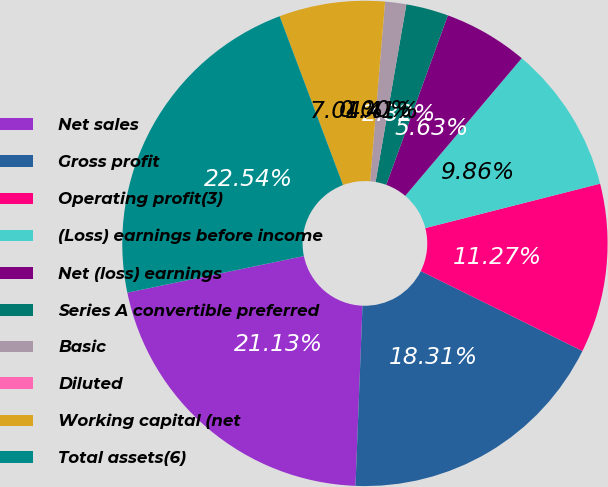<chart> <loc_0><loc_0><loc_500><loc_500><pie_chart><fcel>Net sales<fcel>Gross profit<fcel>Operating profit(3)<fcel>(Loss) earnings before income<fcel>Net (loss) earnings<fcel>Series A convertible preferred<fcel>Basic<fcel>Diluted<fcel>Working capital (net<fcel>Total assets(6)<nl><fcel>21.13%<fcel>18.31%<fcel>11.27%<fcel>9.86%<fcel>5.63%<fcel>2.82%<fcel>1.41%<fcel>0.0%<fcel>7.04%<fcel>22.54%<nl></chart> 